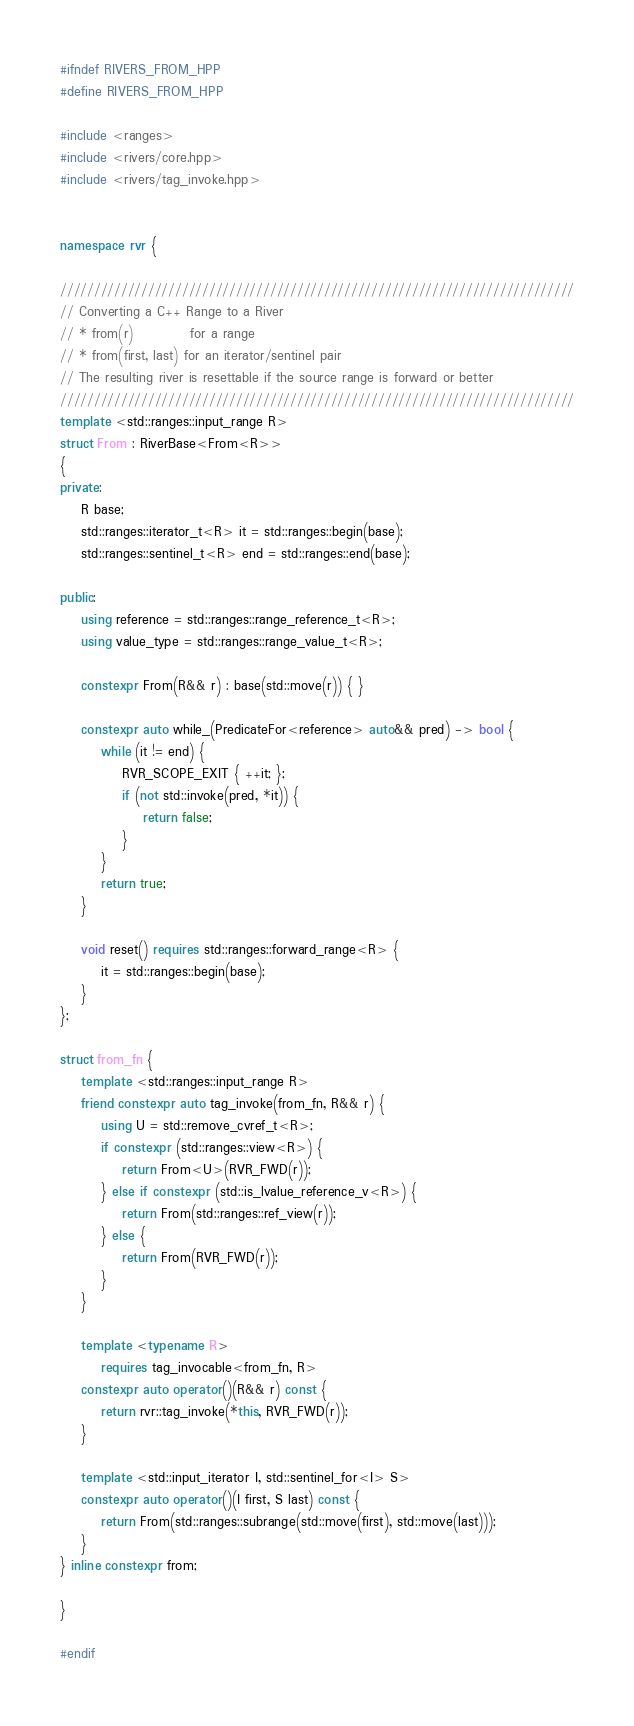<code> <loc_0><loc_0><loc_500><loc_500><_C++_>#ifndef RIVERS_FROM_HPP
#define RIVERS_FROM_HPP

#include <ranges>
#include <rivers/core.hpp>
#include <rivers/tag_invoke.hpp>


namespace rvr {

////////////////////////////////////////////////////////////////////////////
// Converting a C++ Range to a River
// * from(r)           for a range
// * from(first, last) for an iterator/sentinel pair
// The resulting river is resettable if the source range is forward or better
////////////////////////////////////////////////////////////////////////////
template <std::ranges::input_range R>
struct From : RiverBase<From<R>>
{
private:
    R base;
    std::ranges::iterator_t<R> it = std::ranges::begin(base);
    std::ranges::sentinel_t<R> end = std::ranges::end(base);

public:
    using reference = std::ranges::range_reference_t<R>;
    using value_type = std::ranges::range_value_t<R>;

    constexpr From(R&& r) : base(std::move(r)) { }

    constexpr auto while_(PredicateFor<reference> auto&& pred) -> bool {
        while (it != end) {
            RVR_SCOPE_EXIT { ++it; };
            if (not std::invoke(pred, *it)) {
                return false;
            }
        }
        return true;
    }

    void reset() requires std::ranges::forward_range<R> {
        it = std::ranges::begin(base);
    }
};

struct from_fn {
    template <std::ranges::input_range R>
    friend constexpr auto tag_invoke(from_fn, R&& r) {
        using U = std::remove_cvref_t<R>;
        if constexpr (std::ranges::view<R>) {
            return From<U>(RVR_FWD(r));
        } else if constexpr (std::is_lvalue_reference_v<R>) {
            return From(std::ranges::ref_view(r));
        } else {
            return From(RVR_FWD(r));
        }
    }

    template <typename R>
        requires tag_invocable<from_fn, R>
    constexpr auto operator()(R&& r) const {
        return rvr::tag_invoke(*this, RVR_FWD(r));
    }

    template <std::input_iterator I, std::sentinel_for<I> S>
    constexpr auto operator()(I first, S last) const {
        return From(std::ranges::subrange(std::move(first), std::move(last)));
    }
} inline constexpr from;

}

#endif
</code> 